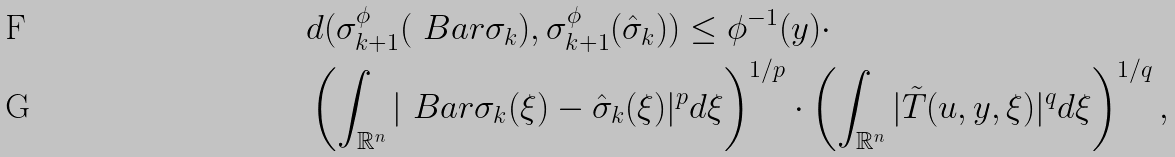<formula> <loc_0><loc_0><loc_500><loc_500>\ \ & d ( \sigma _ { k + 1 } ^ { \phi } ( \ B a r { \sigma } _ { k } ) , \sigma _ { k + 1 } ^ { \phi } ( \hat { \sigma } _ { k } ) ) \leq \phi ^ { - 1 } ( y ) \cdot \\ & \left ( \int _ { \mathbb { R } ^ { n } } | \ B a r { \sigma } _ { k } ( \xi ) - \hat { \sigma } _ { k } ( \xi ) | ^ { p } d \xi \right ) ^ { 1 / p } \cdot \left ( \int _ { \mathbb { R } ^ { n } } | \tilde { T } ( u , y , \xi ) | ^ { q } d \xi \right ) ^ { 1 / q } ,</formula> 